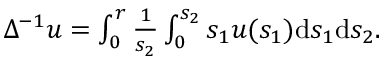<formula> <loc_0><loc_0><loc_500><loc_500>\begin{array} { r } { \Delta ^ { - 1 } u = \int _ { 0 } ^ { r } \frac { 1 } { s _ { 2 } } \int _ { 0 } ^ { s _ { 2 } } s _ { 1 } u ( s _ { 1 } ) d s _ { 1 } d s _ { 2 } . } \end{array}</formula> 